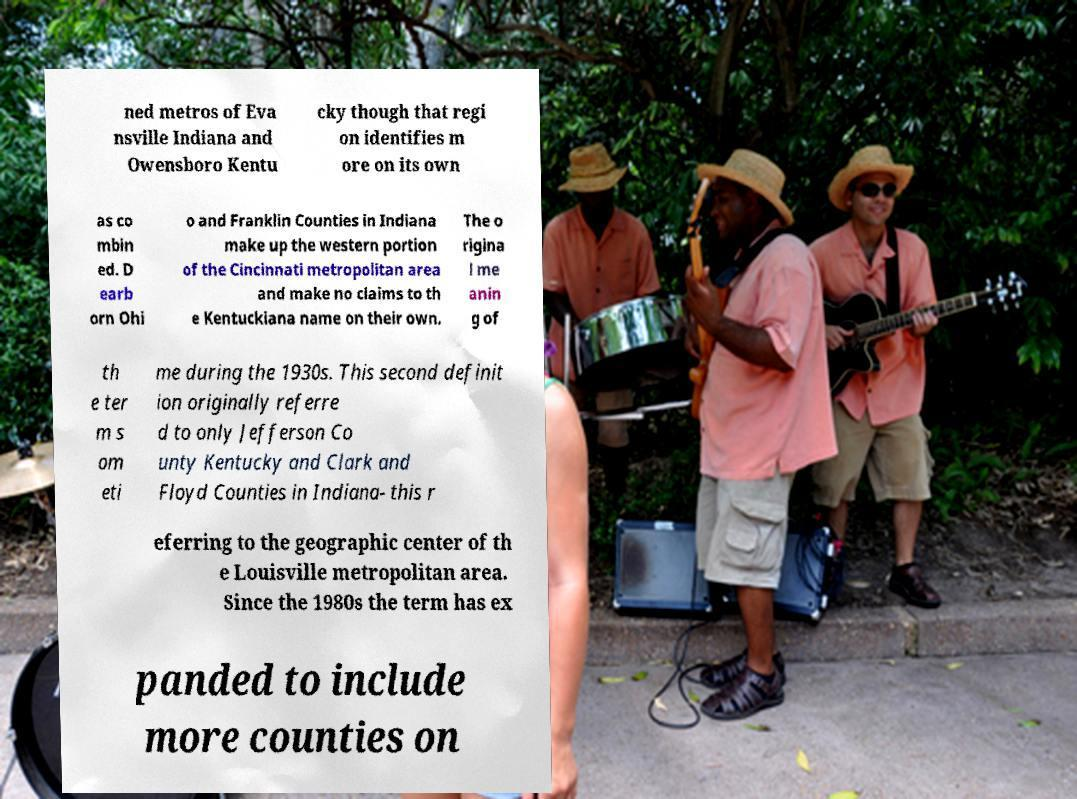Please identify and transcribe the text found in this image. ned metros of Eva nsville Indiana and Owensboro Kentu cky though that regi on identifies m ore on its own as co mbin ed. D earb orn Ohi o and Franklin Counties in Indiana make up the western portion of the Cincinnati metropolitan area and make no claims to th e Kentuckiana name on their own. The o rigina l me anin g of th e ter m s om eti me during the 1930s. This second definit ion originally referre d to only Jefferson Co unty Kentucky and Clark and Floyd Counties in Indiana- this r eferring to the geographic center of th e Louisville metropolitan area. Since the 1980s the term has ex panded to include more counties on 